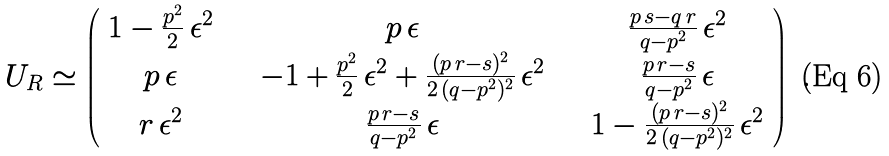Convert formula to latex. <formula><loc_0><loc_0><loc_500><loc_500>U _ { R } \simeq \left ( \begin{array} { c c c } 1 - \frac { p ^ { 2 } } { 2 } \, \epsilon ^ { 2 } & \quad p \, \epsilon & \quad \frac { p \, s - q \, r } { q - p ^ { 2 } } \, \epsilon ^ { 2 } \\ p \, \epsilon & \quad - 1 + \frac { p ^ { 2 } } { 2 } \, \epsilon ^ { 2 } + \frac { ( p \, r - s ) ^ { 2 } } { 2 \, ( q - p ^ { 2 } ) ^ { 2 } } \, \epsilon ^ { 2 } & \quad \frac { p \, r - s } { q - p ^ { 2 } } \, \epsilon \\ r \, \epsilon ^ { 2 } & \quad \frac { p \, r - s } { q - p ^ { 2 } } \, \epsilon & \quad 1 - \frac { ( p \, r - s ) ^ { 2 } } { 2 \, ( q - p ^ { 2 } ) ^ { 2 } } \, \epsilon ^ { 2 } \end{array} \right ) \ .</formula> 